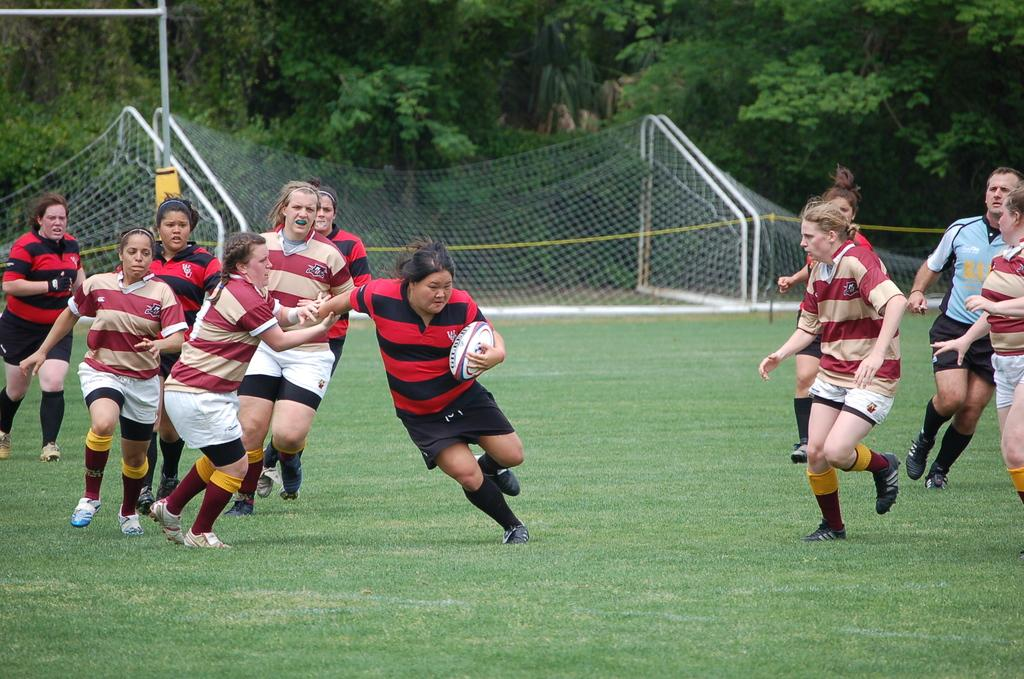What are the people in the image doing? The people in the image are playing on the ground. Can you describe what one person is holding? One person is holding a ball in her hand. What can be seen in the background of the image? There is a net and a metal structure in the background of the image, as well as trees. What type of spark can be seen coming from the ball in the image? There is no spark coming from the ball in the image; it is a regular ball being held by one of the people. Can you describe the heart-shaped pattern on the ground in the image? There is no heart-shaped pattern on the ground in the image; the ground is simply a grassy area where people are playing. 